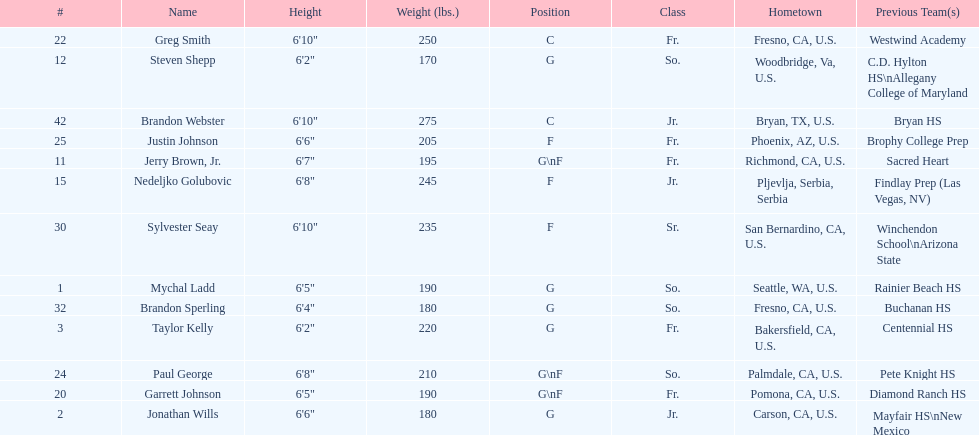Taylor kelly is shorter than 6' 3", which other player is also shorter than 6' 3"? Steven Shepp. I'm looking to parse the entire table for insights. Could you assist me with that? {'header': ['#', 'Name', 'Height', 'Weight (lbs.)', 'Position', 'Class', 'Hometown', 'Previous Team(s)'], 'rows': [['22', 'Greg Smith', '6\'10"', '250', 'C', 'Fr.', 'Fresno, CA, U.S.', 'Westwind Academy'], ['12', 'Steven Shepp', '6\'2"', '170', 'G', 'So.', 'Woodbridge, Va, U.S.', 'C.D. Hylton HS\\nAllegany College of Maryland'], ['42', 'Brandon Webster', '6\'10"', '275', 'C', 'Jr.', 'Bryan, TX, U.S.', 'Bryan HS'], ['25', 'Justin Johnson', '6\'6"', '205', 'F', 'Fr.', 'Phoenix, AZ, U.S.', 'Brophy College Prep'], ['11', 'Jerry Brown, Jr.', '6\'7"', '195', 'G\\nF', 'Fr.', 'Richmond, CA, U.S.', 'Sacred Heart'], ['15', 'Nedeljko Golubovic', '6\'8"', '245', 'F', 'Jr.', 'Pljevlja, Serbia, Serbia', 'Findlay Prep (Las Vegas, NV)'], ['30', 'Sylvester Seay', '6\'10"', '235', 'F', 'Sr.', 'San Bernardino, CA, U.S.', 'Winchendon School\\nArizona State'], ['1', 'Mychal Ladd', '6\'5"', '190', 'G', 'So.', 'Seattle, WA, U.S.', 'Rainier Beach HS'], ['32', 'Brandon Sperling', '6\'4"', '180', 'G', 'So.', 'Fresno, CA, U.S.', 'Buchanan HS'], ['3', 'Taylor Kelly', '6\'2"', '220', 'G', 'Fr.', 'Bakersfield, CA, U.S.', 'Centennial HS'], ['24', 'Paul George', '6\'8"', '210', 'G\\nF', 'So.', 'Palmdale, CA, U.S.', 'Pete Knight HS'], ['20', 'Garrett Johnson', '6\'5"', '190', 'G\\nF', 'Fr.', 'Pomona, CA, U.S.', 'Diamond Ranch HS'], ['2', 'Jonathan Wills', '6\'6"', '180', 'G', 'Jr.', 'Carson, CA, U.S.', 'Mayfair HS\\nNew Mexico']]} 